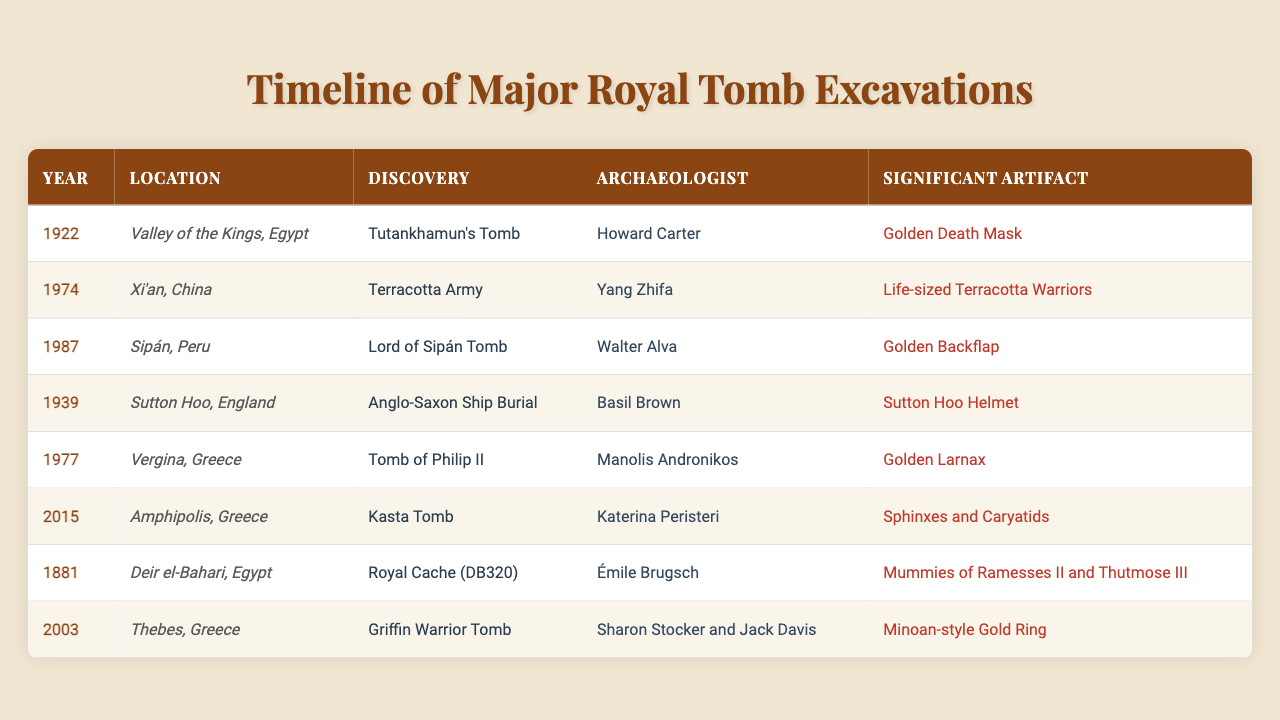What year was Tutankhamun's Tomb discovered? Tutankhamun's Tomb was discovered in 1922, as indicated in the table.
Answer: 1922 Who was the archaeologist that discovered the Terracotta Army? The table states that the Terracotta Army was discovered by Yang Zhifa in 1974.
Answer: Yang Zhifa Which tomb discovery is associated with a significant artifact called the Golden Larnax? According to the table, the Golden Larnax is associated with the Tomb of Philip II, discovered in 1977.
Answer: Tomb of Philip II Is the Griffin Warrior Tomb located in Greece? The table shows that the Griffin Warrior Tomb was discovered in Thebes, Greece, confirming that it is indeed located there.
Answer: Yes What is the time gap between the discovery of Tutankhamun's Tomb and the Lord of Sipán Tomb? Tutankhamun's Tomb was discovered in 1922 and the Lord of Sipán Tomb in 1987; the time gap is 1987 - 1922 = 65 years.
Answer: 65 years How many significant artifacts are listed for excavations after 1970? There are four important artifacts listed for excavations after 1970: Terracotta Warriors (1974), Golden Larnax (1977), Sphinxes and Caryatids (2015), and the Minoan-style Gold Ring (2003).
Answer: 4 Which excavation has the earliest date in the table and what artifact is noted? The earliest excavation in the table is the Royal Cache (DB320) from 1881, with the significant artifact being the Mummies of Ramesses II and Thutmose III.
Answer: Royal Cache (DB320), Mummies of Ramesses II and Thutmose III Considering all the discoveries, which location had the latest excavation year and what was discovered there? The latest excavation year mentioned is 2015, at Amphipolis, Greece, where the Kasta Tomb was discovered.
Answer: Kasta Tomb Was the Sutton Hoo excavation conducted by a renowned archaeologist? Yes, the Sutton Hoo excavation was conducted by Basil Brown, who is recognized for his significant contributions.
Answer: Yes Identify the artifact associated with the discovery of the Anglo-Saxon Ship Burial. The significant artifact associated with the Anglo-Saxon Ship Burial is the Sutton Hoo Helmet, as detailed in the table.
Answer: Sutton Hoo Helmet 